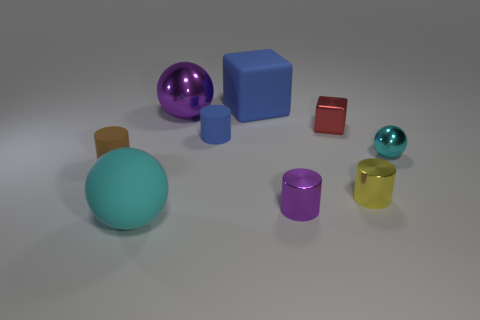Subtract all small brown matte cylinders. How many cylinders are left? 3 Subtract 2 spheres. How many spheres are left? 1 Subtract all yellow cylinders. How many cylinders are left? 3 Subtract all blocks. How many objects are left? 7 Subtract all green blocks. How many gray spheres are left? 0 Subtract all gray cylinders. Subtract all brown cubes. How many cylinders are left? 4 Subtract all small green things. Subtract all brown matte objects. How many objects are left? 8 Add 4 large cyan rubber balls. How many large cyan rubber balls are left? 5 Add 8 small blue cylinders. How many small blue cylinders exist? 9 Subtract 0 gray blocks. How many objects are left? 9 